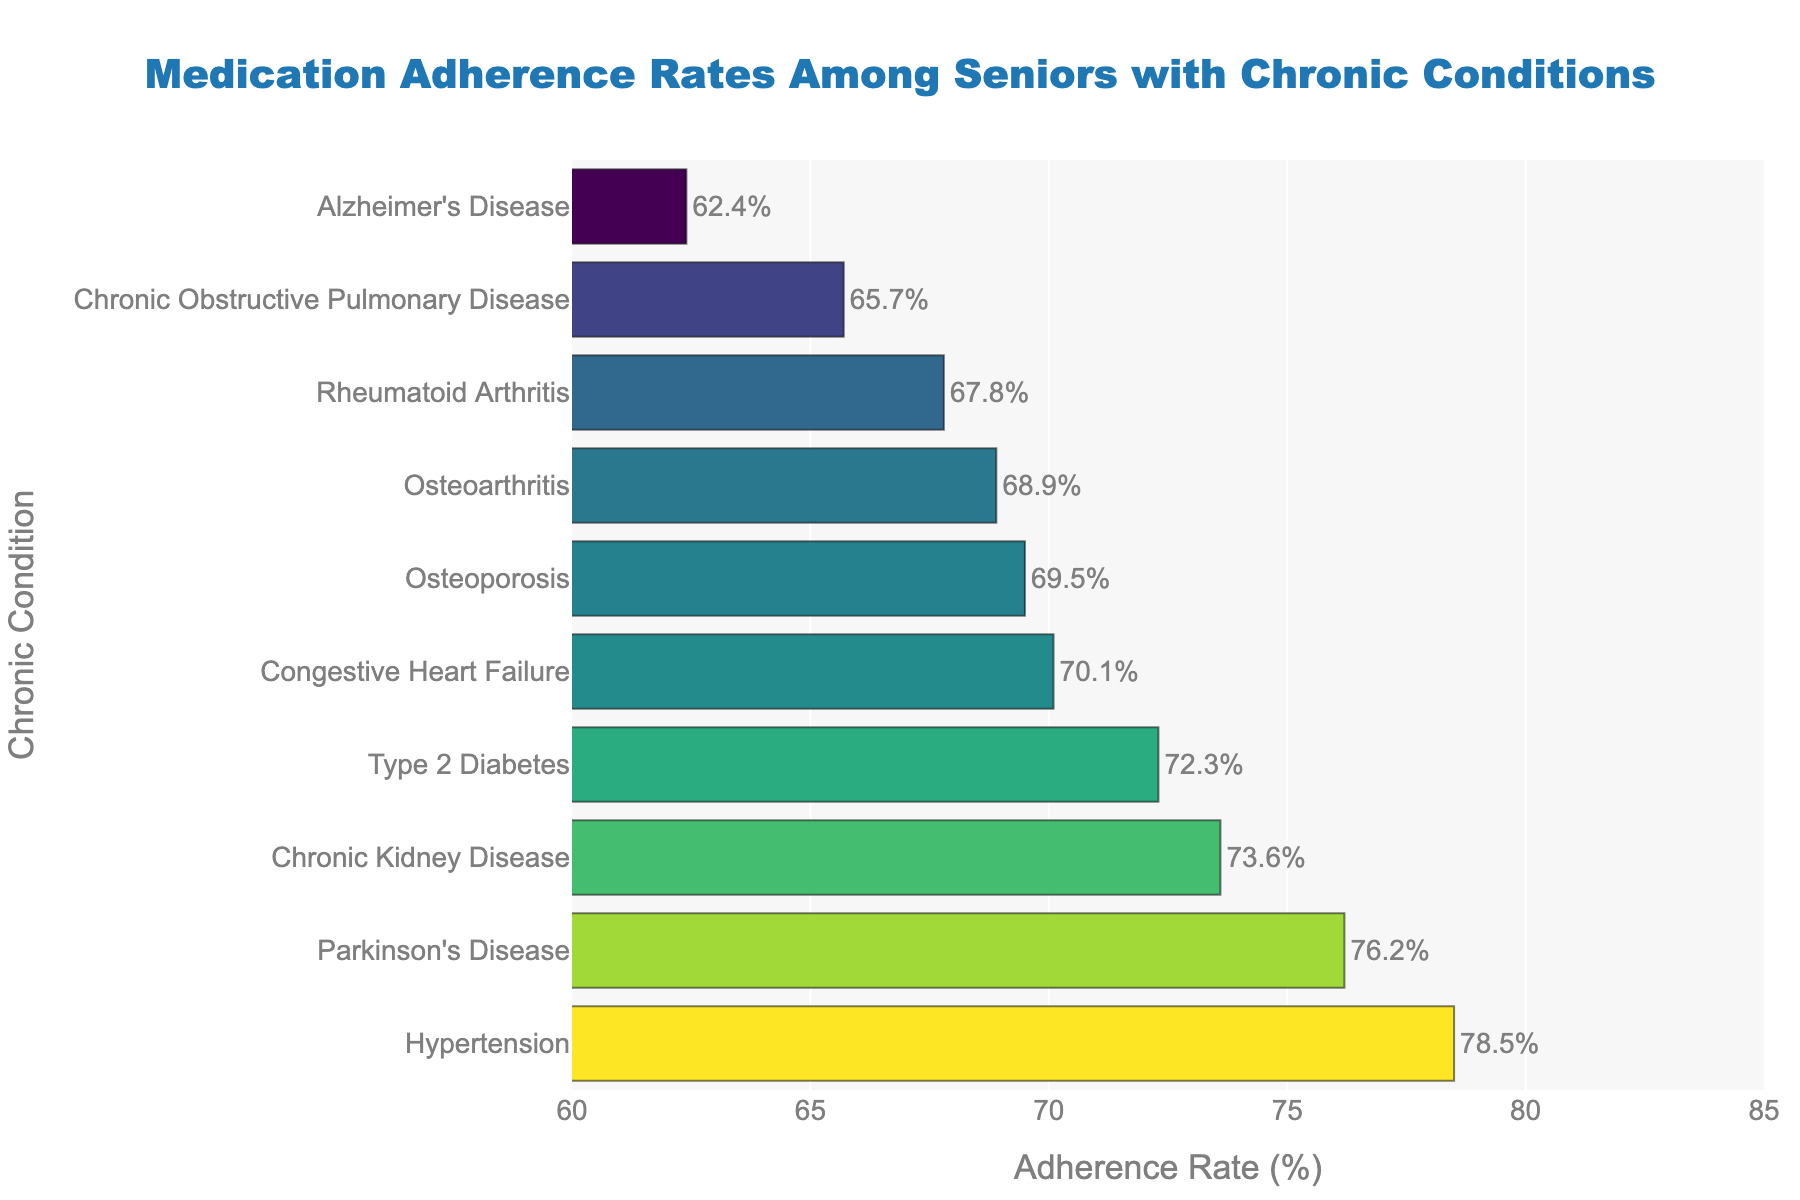Which chronic condition has the highest medication adherence rate? To identify the condition with the highest medication adherence rate, look for the longest bar on the chart and check the corresponding condition. The longest bar corresponds to "Hypertension" with an adherence rate of 78.5%.
Answer: Hypertension Which chronic condition has the lowest medication adherence rate? To find the condition with the lowest adherence rate, look for the shortest bar on the chart and check the corresponding condition. The shortest bar corresponds to "Alzheimer's Disease" with an adherence rate of 62.4%.
Answer: Alzheimer's Disease What is the difference in adherence rates between Hypertension and Alzheimer's Disease? First, identify the adherence rates for both conditions: Hypertension (78.5%) and Alzheimer's Disease (62.4%). Then, subtract the adherence rate of Alzheimer's Disease from Hypertension: 78.5% - 62.4% = 16.1%.
Answer: 16.1% Which condition has a higher medication adherence rate, Type 2 Diabetes or Chronic Kidney Disease? Locate the adherence rates for both conditions: Type 2 Diabetes (72.3%) and Chronic Kidney Disease (73.6%). Compare them to see which is higher. Chronic Kidney Disease has a higher rate.
Answer: Chronic Kidney Disease Are there any conditions with adherence rates between 67% and 70%? Look for bars with adherence rates falling between 67% and 70%. These conditions are Rheumatoid Arthritis (67.8%), Osteoporosis (69.5%), and Osteoarthritis (68.9%).
Answer: Rheumatoid Arthritis, Osteoporosis, Osteoarthritis What is the average adherence rate for Hypertension, Congestive Heart Failure, and Parkinson's Disease? Identify the adherence rates for Hypertension (78.5%), Congestive Heart Failure (70.1%), and Parkinson's Disease (76.2%). Calculate the average: (78.5% + 70.1% + 76.2%) / 3 = 224.8% / 3 ≈ 74.93%.
Answer: 74.93% If a medication with an adherence rate below 70% is considered problematic, which conditions fall into this category? Identify conditions with adherence rates below 70%: Osteoarthritis (68.9%), Chronic Obstructive Pulmonary Disease (65.7%), Rheumatoid Arthritis (67.8%), Alzheimer's Disease (62.4%), and Osteoporosis (69.5%).
Answer: Osteoarthritis, Chronic Obstructive Pulmonary Disease, Rheumatoid Arthritis, Alzheimer's Disease, Osteoporosis How many conditions have an adherence rate higher than 75%? Look for bars with adherence rates higher than 75%. Count the bars: Hypertension (78.5%), and Parkinson's Disease (76.2%).
Answer: 2 Which condition has a similar medication adherence rate to Congestive Heart Failure? Identify the adherence rate for Congestive Heart Failure (70.1%). Find the condition with a similar adherence rate: none are exactly the same, but Type 2 Diabetes (72.3%) and Osteoporosis (69.5%) are close.
Answer: None exactly; closest are Type 2 Diabetes and Osteoporosis What is the range of adherence rates presented in the chart? Determine the range by subtracting the lowest adherence rate from the highest. The highest rate is for Hypertension (78.5%) and the lowest is for Alzheimer's Disease (62.4%): 78.5% - 62.4% = 16.1%.
Answer: 16.1% 